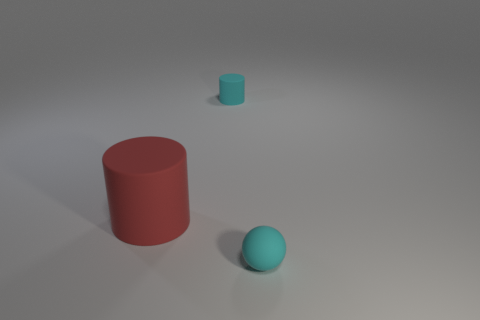What number of other things are the same shape as the big red rubber thing?
Offer a very short reply. 1. What number of other objects are the same material as the big object?
Keep it short and to the point. 2. There is another cyan thing that is the same shape as the large rubber object; what is its size?
Your response must be concise. Small. Is the color of the small rubber sphere the same as the tiny cylinder?
Offer a very short reply. Yes. What color is the rubber thing that is both on the right side of the big matte cylinder and on the left side of the cyan matte sphere?
Give a very brief answer. Cyan. What number of things are small matte things behind the big object or tiny green metallic things?
Your response must be concise. 1. There is another rubber thing that is the same shape as the large red rubber object; what color is it?
Your answer should be compact. Cyan. Is the shape of the large object the same as the tiny cyan object that is in front of the large cylinder?
Ensure brevity in your answer.  No. How many objects are matte cylinders behind the red cylinder or cyan matte objects in front of the tiny cyan cylinder?
Your answer should be compact. 2. Is the number of red cylinders that are behind the big rubber thing less than the number of brown cylinders?
Provide a short and direct response. No. 